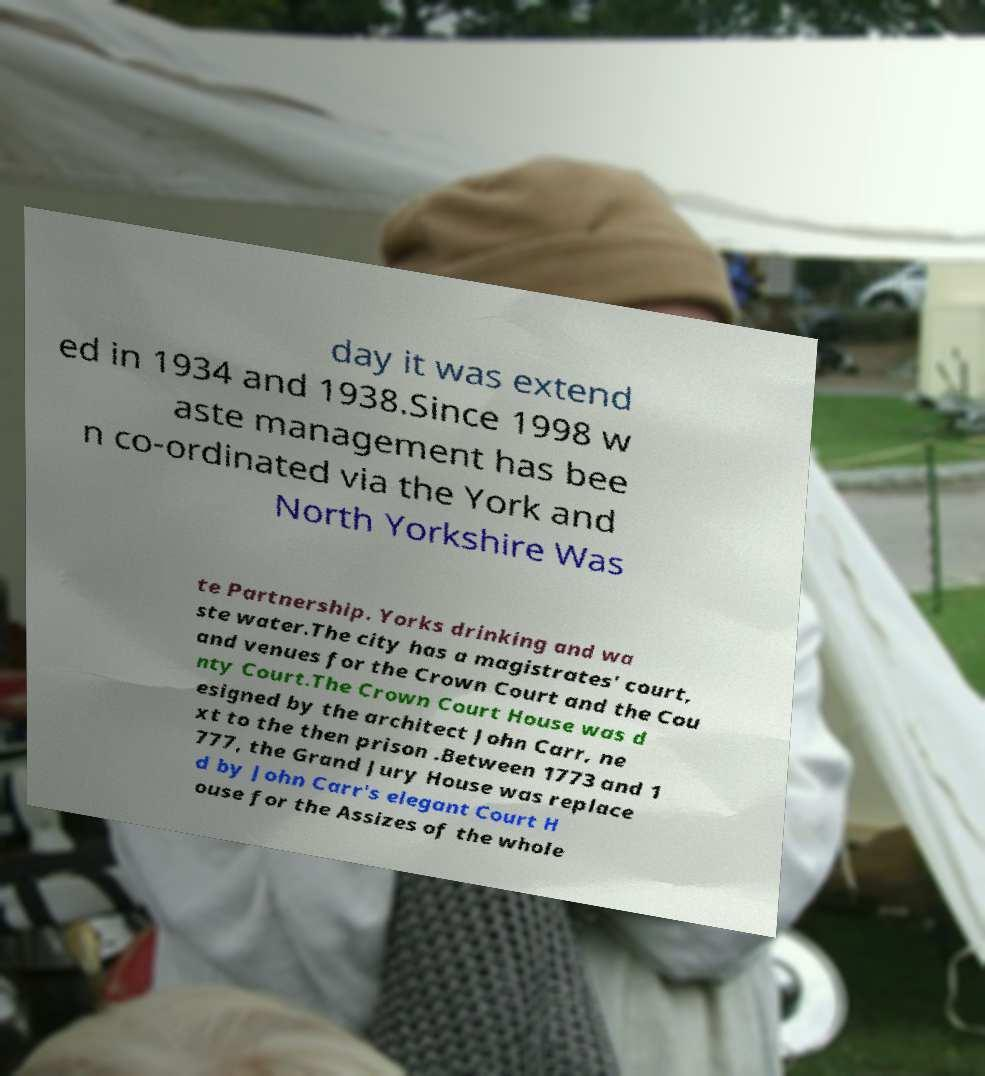Can you read and provide the text displayed in the image?This photo seems to have some interesting text. Can you extract and type it out for me? day it was extend ed in 1934 and 1938.Since 1998 w aste management has bee n co-ordinated via the York and North Yorkshire Was te Partnership. Yorks drinking and wa ste water.The city has a magistrates' court, and venues for the Crown Court and the Cou nty Court.The Crown Court House was d esigned by the architect John Carr, ne xt to the then prison .Between 1773 and 1 777, the Grand Jury House was replace d by John Carr's elegant Court H ouse for the Assizes of the whole 